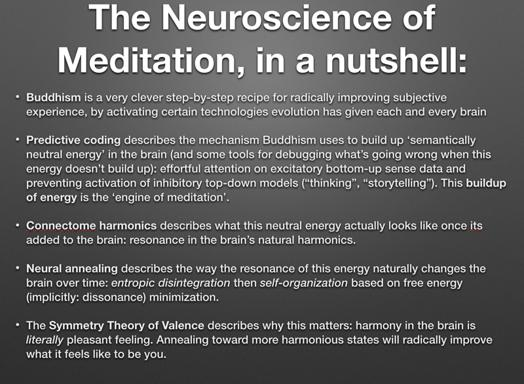Can you explain how connectome harmonics play a role in meditation as described in the text? The text describes connectome harmonics as the visual representation of energy states in the brain, resembling patterns that emerge during meditation. This process potentially aids in achieving a balanced mental state by aligning brain frequencies to more stable, harmonious configurations. What practical outcomes might this alignment lead to? This alignment may enhance mental clarity, emotional stability, and resilience against stress by promoting a smoother and more synchronous brain activity pattern, which is critical for effective mental processing and a peaceful state of mind. 